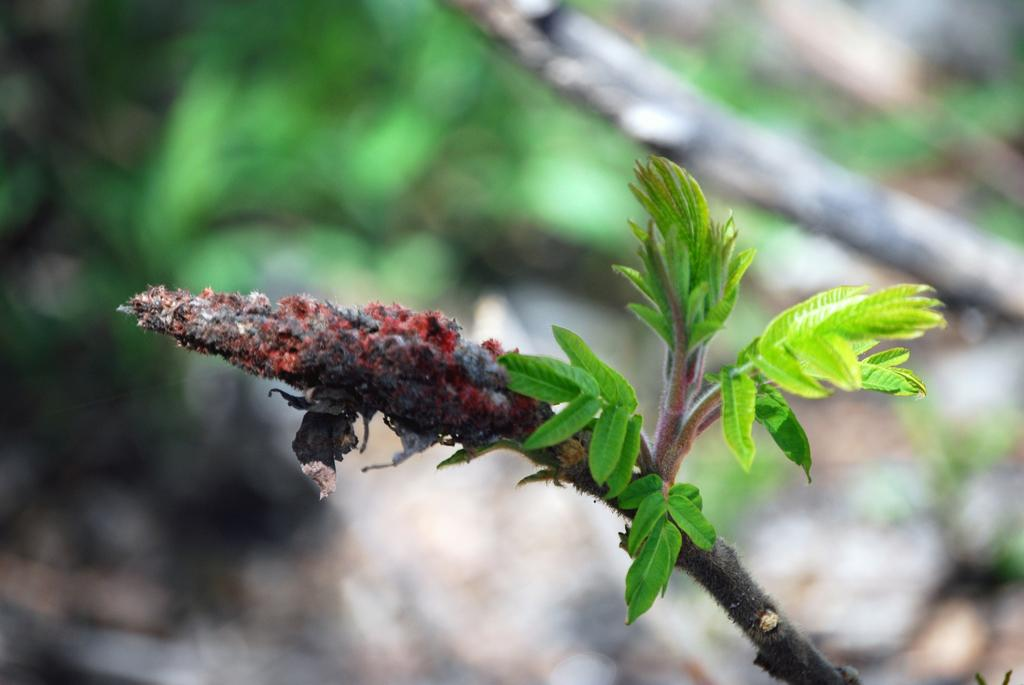What is located in the foreground of the image? There is a plant in the foreground of the image. What can be seen in the background of the image? There are trees in the background of the image. How many types of vegetation are visible in the image? There are two types of vegetation visible: a plant in the foreground and trees in the background. What language is spoken by the plant in the image? Plants do not speak languages, so this question cannot be answered. 